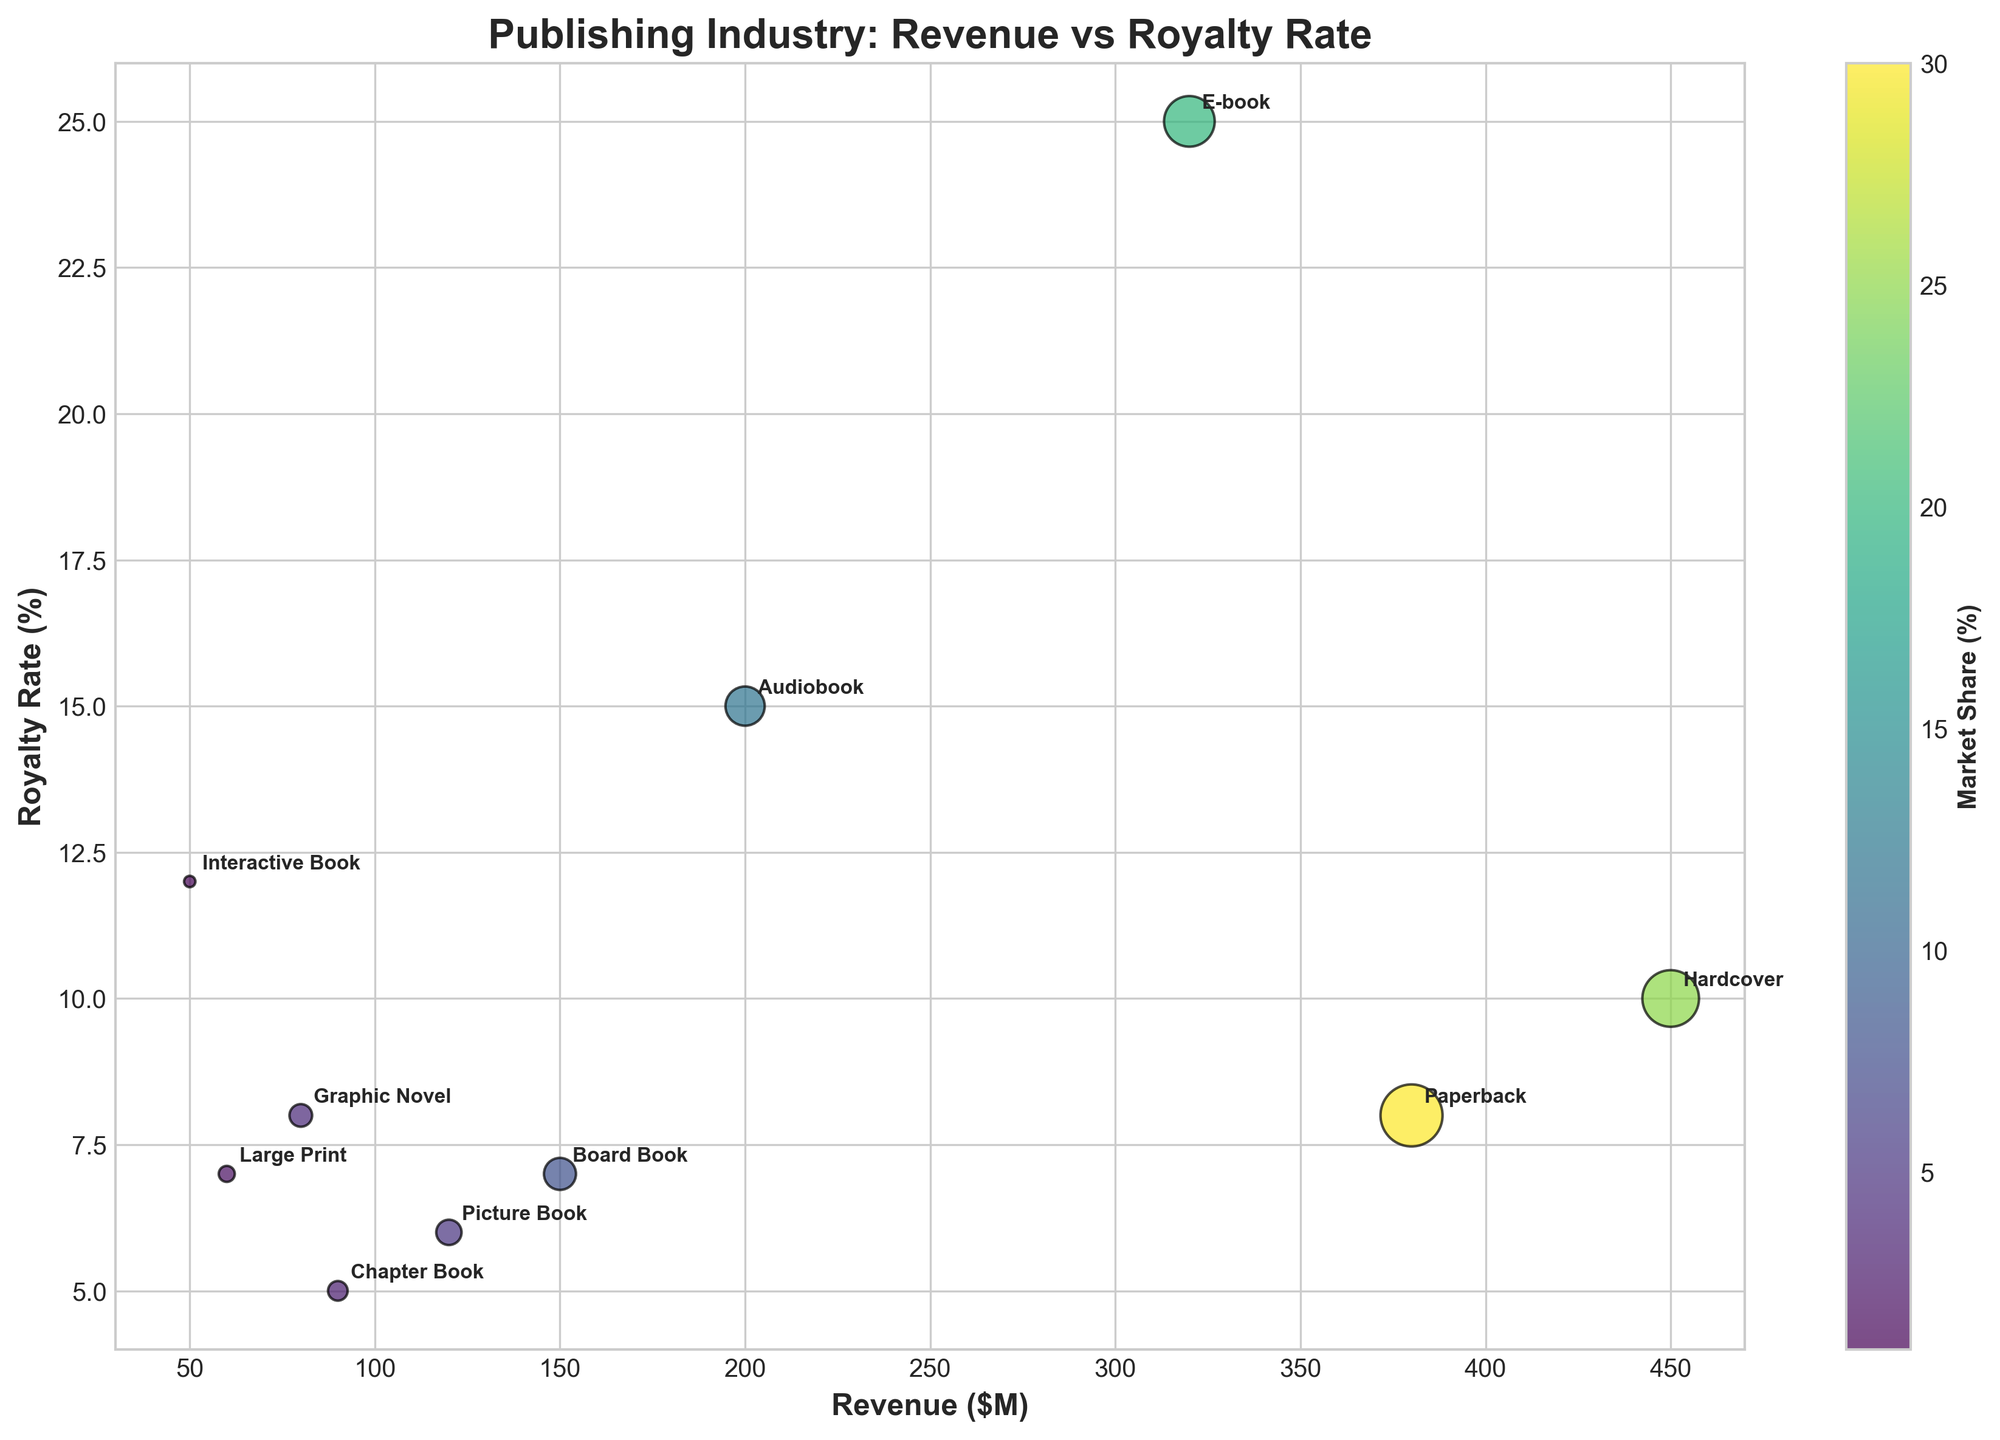How many book formats are represented in the biplot? There are unique points on the scatter plot representing different book formats. By counting the names next to each point, we see 10 unique formats.
Answer: 10 Which book format has the highest royalty rate? By visually inspecting the y-axis and the points' labels, the E-book format has the highest royalty rate of 25%.
Answer: E-book What is the total market share of Paperback and E-book formats combined? The market share for Paperback is 30% and for E-book is 20%. Adding them together: 30 + 20 = 50%.
Answer: 50% Which format earns the highest revenue? By looking at the points on the x-axis, Hardcover format is positioned furthest right, indicating it has the highest revenue of $450M.
Answer: Hardcover How does the market share of Picture Books compare to Board Books? Picture Books have a market share of 5%, while Board Books have 8%. Comparing the two, Picture Books have a lower market share.
Answer: Picture Books have a lower market share Which book formats have a revenue of less than $100M? Points to the left of the $100M mark on the x-axis represent these formats: Chapter Book ($90M), Graphic Novel ($80M), Large Print ($60M), and Interactive Book ($50M).
Answer: Chapter Book, Graphic Novel, Large Print, Interactive Book What is the average royalty rate for formats that have a revenue above $300M? Hardcover (10%), Paperback (8%), and E-book (25%) all have revenues above $300M. Average royalty rate: (10 + 8 + 25) / 3 = 14.33%.
Answer: 14.33% Which format has the highest market share and what is its royalty rate? Paperback has the highest market share of 30%. By checking its point in the plot, the royalty rate is 8%.
Answer: 8% Is there a book format with both low revenue and high royalty rate? Interactive Book has low revenue ($50M) but a relatively high royalty rate (12%).
Answer: Interactive Book Between Audiobooks and Picture Books, which format provides a higher royalty rate? By comparing their points on the y-axis, Audiobooks have a higher royalty rate (15%) compared to Picture Books (6%).
Answer: Audiobook 